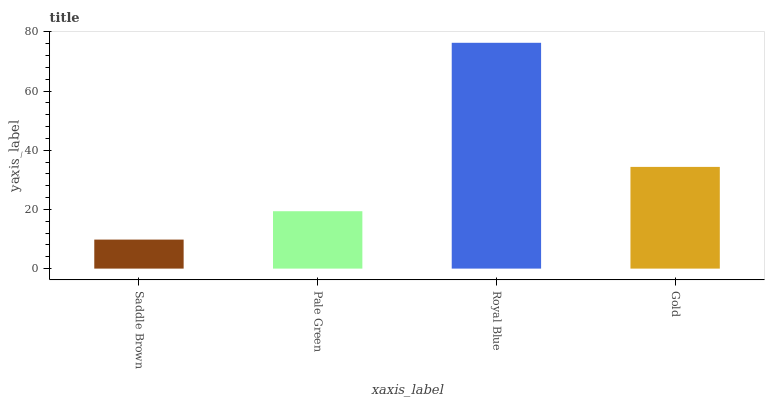Is Saddle Brown the minimum?
Answer yes or no. Yes. Is Royal Blue the maximum?
Answer yes or no. Yes. Is Pale Green the minimum?
Answer yes or no. No. Is Pale Green the maximum?
Answer yes or no. No. Is Pale Green greater than Saddle Brown?
Answer yes or no. Yes. Is Saddle Brown less than Pale Green?
Answer yes or no. Yes. Is Saddle Brown greater than Pale Green?
Answer yes or no. No. Is Pale Green less than Saddle Brown?
Answer yes or no. No. Is Gold the high median?
Answer yes or no. Yes. Is Pale Green the low median?
Answer yes or no. Yes. Is Saddle Brown the high median?
Answer yes or no. No. Is Royal Blue the low median?
Answer yes or no. No. 